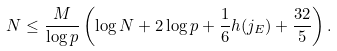<formula> <loc_0><loc_0><loc_500><loc_500>N \leq \frac { M } { \log p } \left ( \log N + 2 \log p + \frac { 1 } { 6 } h ( j _ { E } ) + \frac { 3 2 } { 5 } \right ) .</formula> 